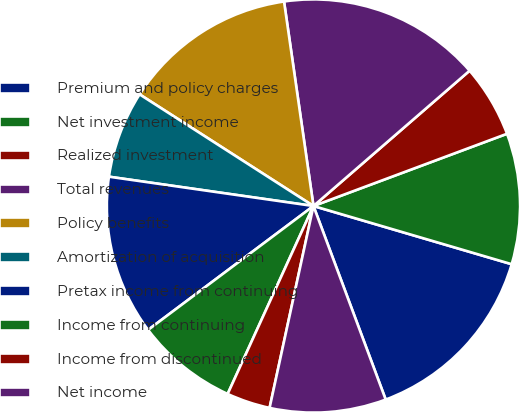Convert chart to OTSL. <chart><loc_0><loc_0><loc_500><loc_500><pie_chart><fcel>Premium and policy charges<fcel>Net investment income<fcel>Realized investment<fcel>Total revenues<fcel>Policy benefits<fcel>Amortization of acquisition<fcel>Pretax income from continuing<fcel>Income from continuing<fcel>Income from discontinued<fcel>Net income<nl><fcel>14.77%<fcel>10.23%<fcel>5.68%<fcel>15.91%<fcel>13.64%<fcel>6.82%<fcel>12.5%<fcel>7.95%<fcel>3.41%<fcel>9.09%<nl></chart> 